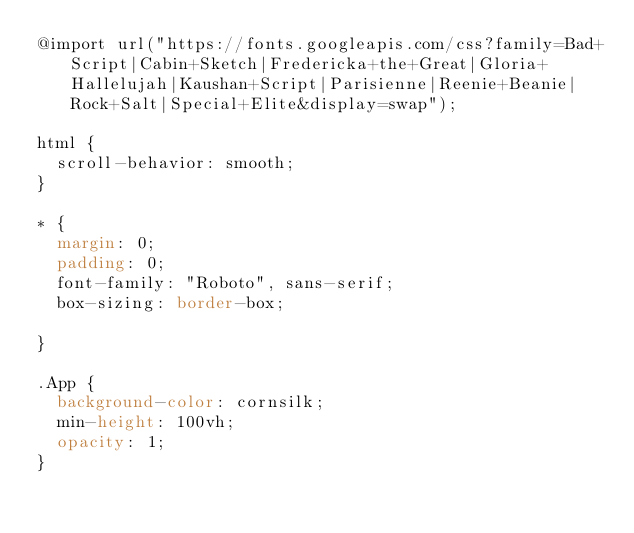Convert code to text. <code><loc_0><loc_0><loc_500><loc_500><_CSS_>@import url("https://fonts.googleapis.com/css?family=Bad+Script|Cabin+Sketch|Fredericka+the+Great|Gloria+Hallelujah|Kaushan+Script|Parisienne|Reenie+Beanie|Rock+Salt|Special+Elite&display=swap");

html {
  scroll-behavior: smooth;
}

* {
  margin: 0;
  padding: 0;
  font-family: "Roboto", sans-serif;
  box-sizing: border-box;

}

.App {
  background-color: cornsilk;
  min-height: 100vh;
  opacity: 1;
}
</code> 